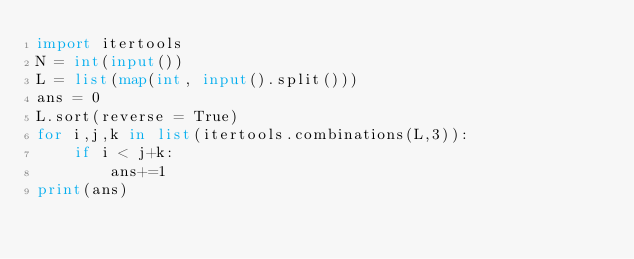<code> <loc_0><loc_0><loc_500><loc_500><_Python_>import itertools
N = int(input())
L = list(map(int, input().split()))
ans = 0
L.sort(reverse = True)
for i,j,k in list(itertools.combinations(L,3)):
    if i < j+k:
        ans+=1
print(ans)</code> 